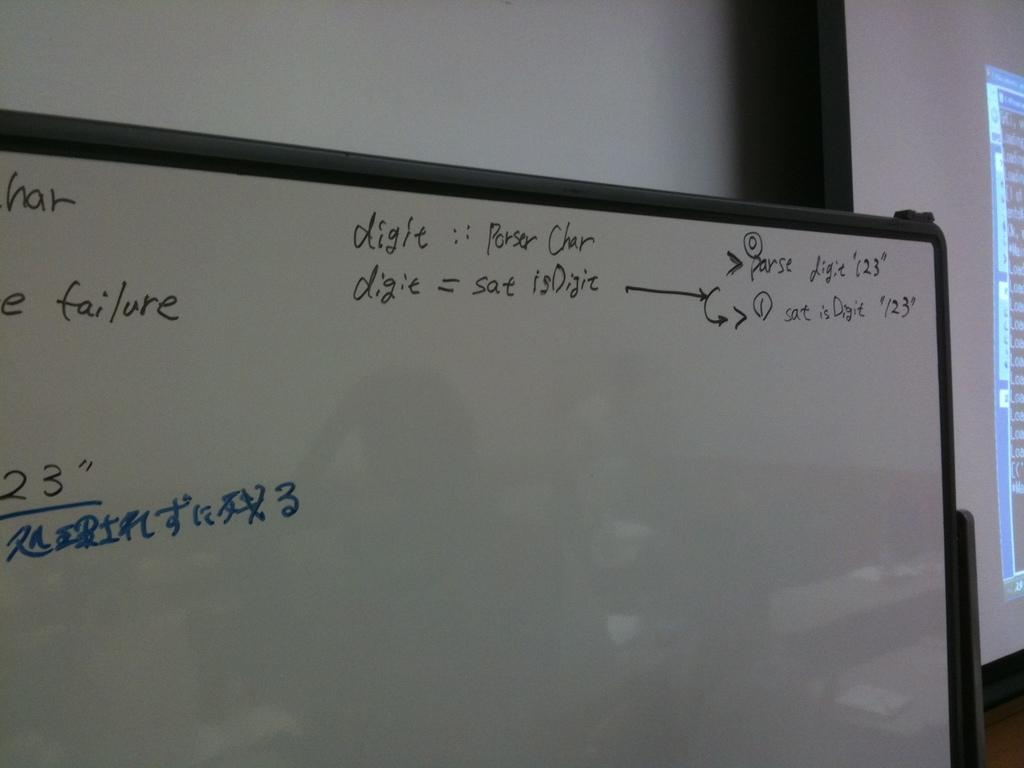Provide a one-sentence caption for the provided image. A white board with words like digie and failure written on it. 